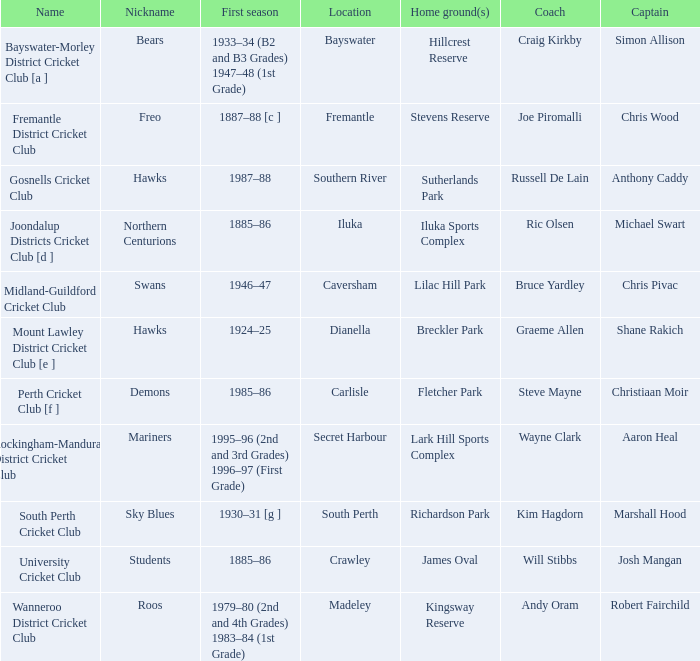Where is the venue for the club dubbed the bears? Bayswater. 